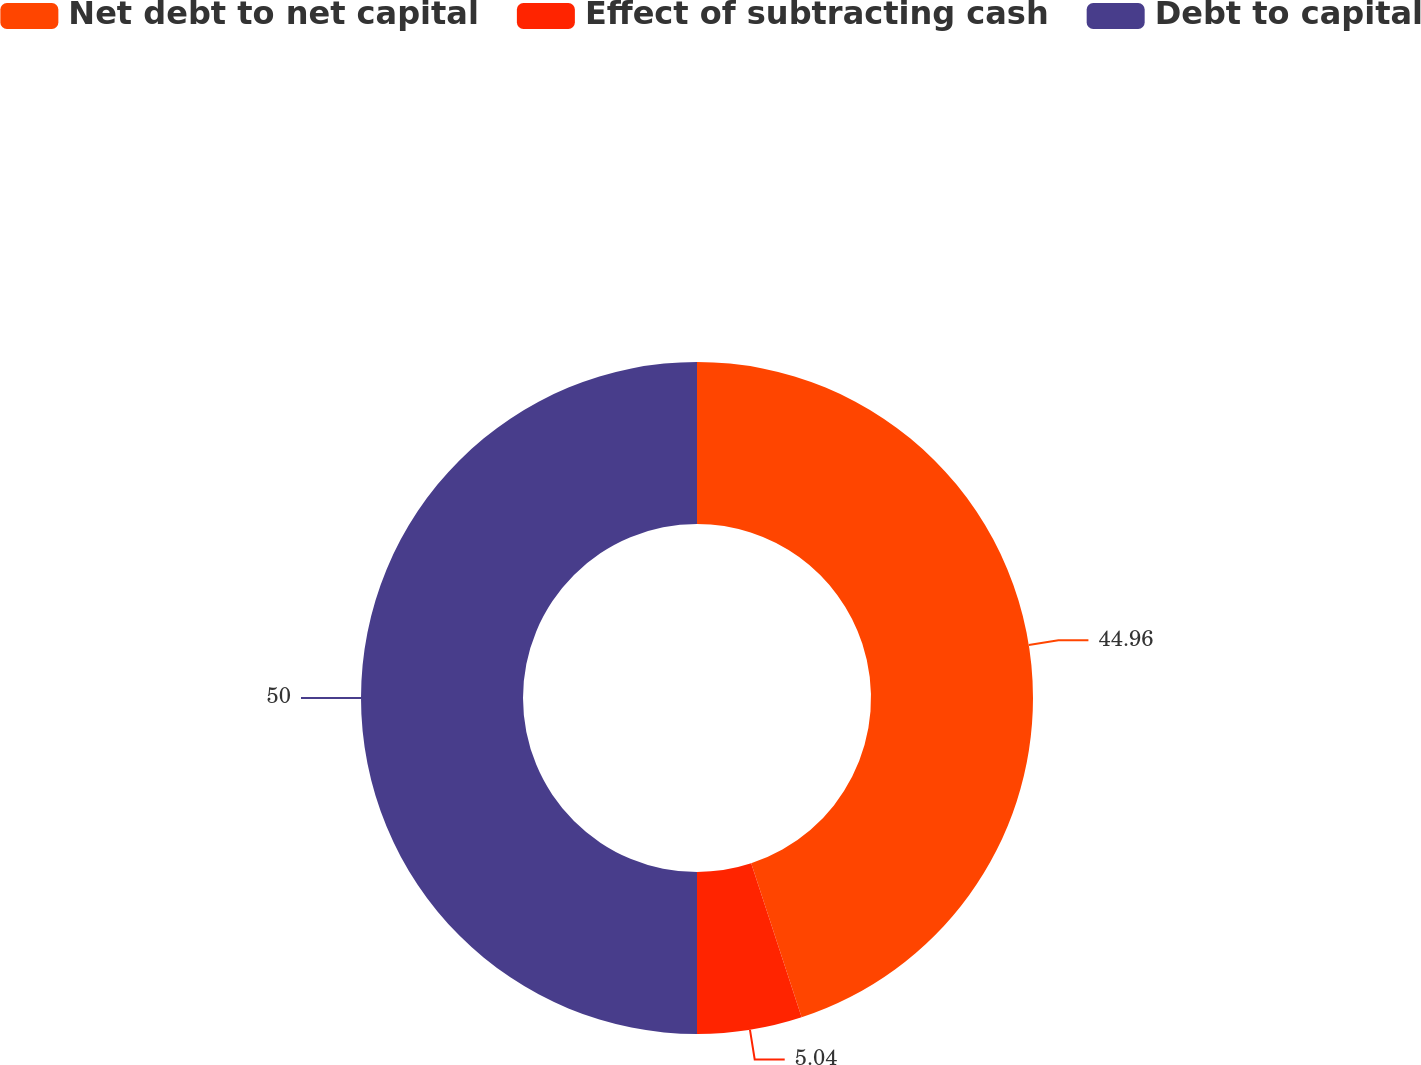Convert chart. <chart><loc_0><loc_0><loc_500><loc_500><pie_chart><fcel>Net debt to net capital<fcel>Effect of subtracting cash<fcel>Debt to capital<nl><fcel>44.96%<fcel>5.04%<fcel>50.0%<nl></chart> 